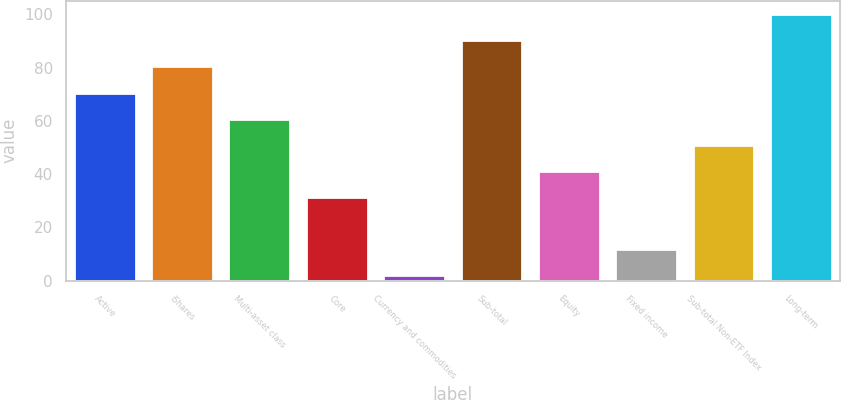<chart> <loc_0><loc_0><loc_500><loc_500><bar_chart><fcel>Active<fcel>iShares<fcel>Multi-asset class<fcel>Core<fcel>Currency and commodities<fcel>Sub-total<fcel>Equity<fcel>Fixed income<fcel>Sub-total Non-ETF Index<fcel>Long-term<nl><fcel>70.6<fcel>80.4<fcel>60.8<fcel>31.4<fcel>2<fcel>90.2<fcel>41.2<fcel>11.8<fcel>51<fcel>100<nl></chart> 